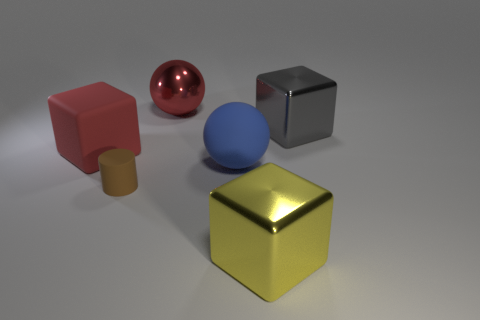Add 1 gray metal things. How many objects exist? 7 Subtract all red rubber blocks. How many blocks are left? 2 Subtract all red spheres. How many spheres are left? 1 Subtract 1 blocks. How many blocks are left? 2 Subtract all purple spheres. Subtract all green blocks. How many spheres are left? 2 Subtract all red blocks. How many red balls are left? 1 Subtract all tiny brown objects. Subtract all yellow metallic objects. How many objects are left? 4 Add 6 rubber objects. How many rubber objects are left? 9 Add 5 red rubber things. How many red rubber things exist? 6 Subtract 0 green balls. How many objects are left? 6 